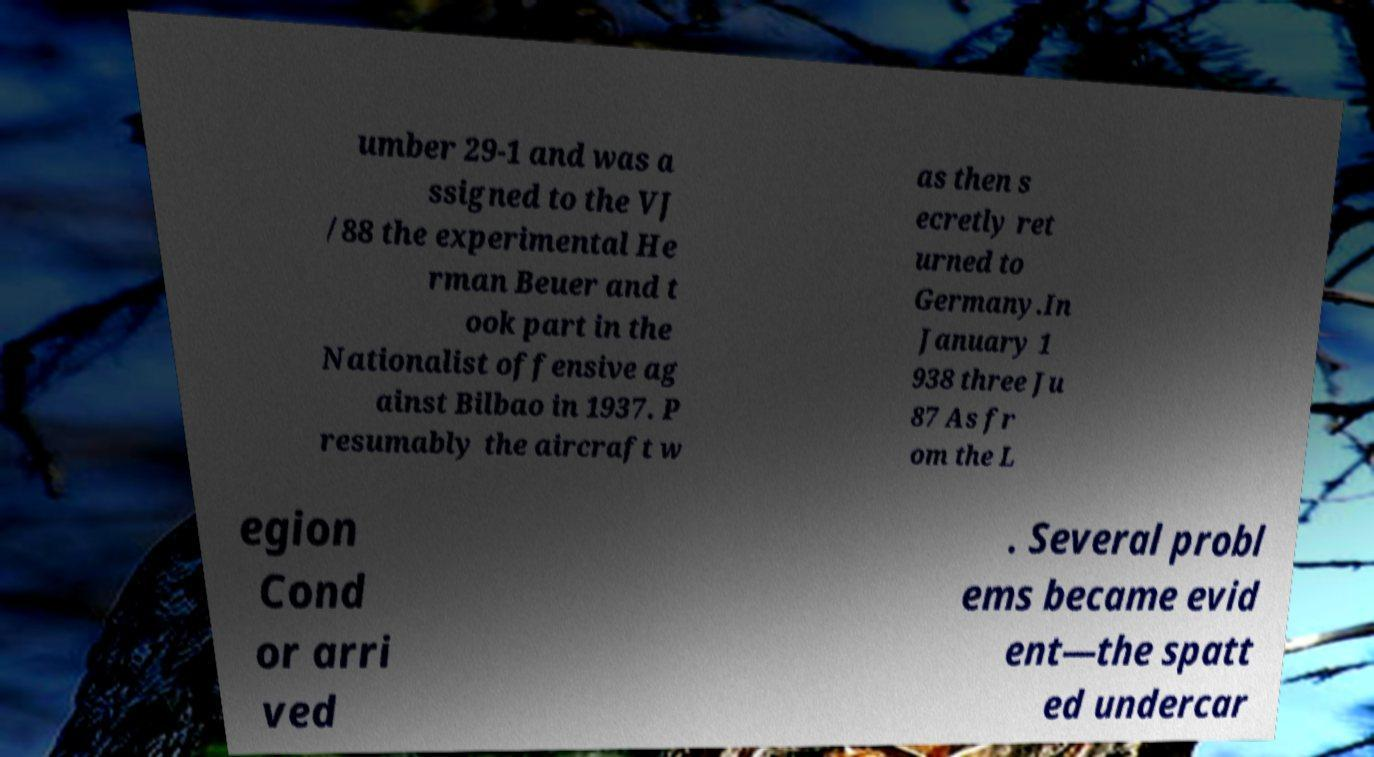Could you assist in decoding the text presented in this image and type it out clearly? umber 29-1 and was a ssigned to the VJ /88 the experimental He rman Beuer and t ook part in the Nationalist offensive ag ainst Bilbao in 1937. P resumably the aircraft w as then s ecretly ret urned to Germany.In January 1 938 three Ju 87 As fr om the L egion Cond or arri ved . Several probl ems became evid ent—the spatt ed undercar 